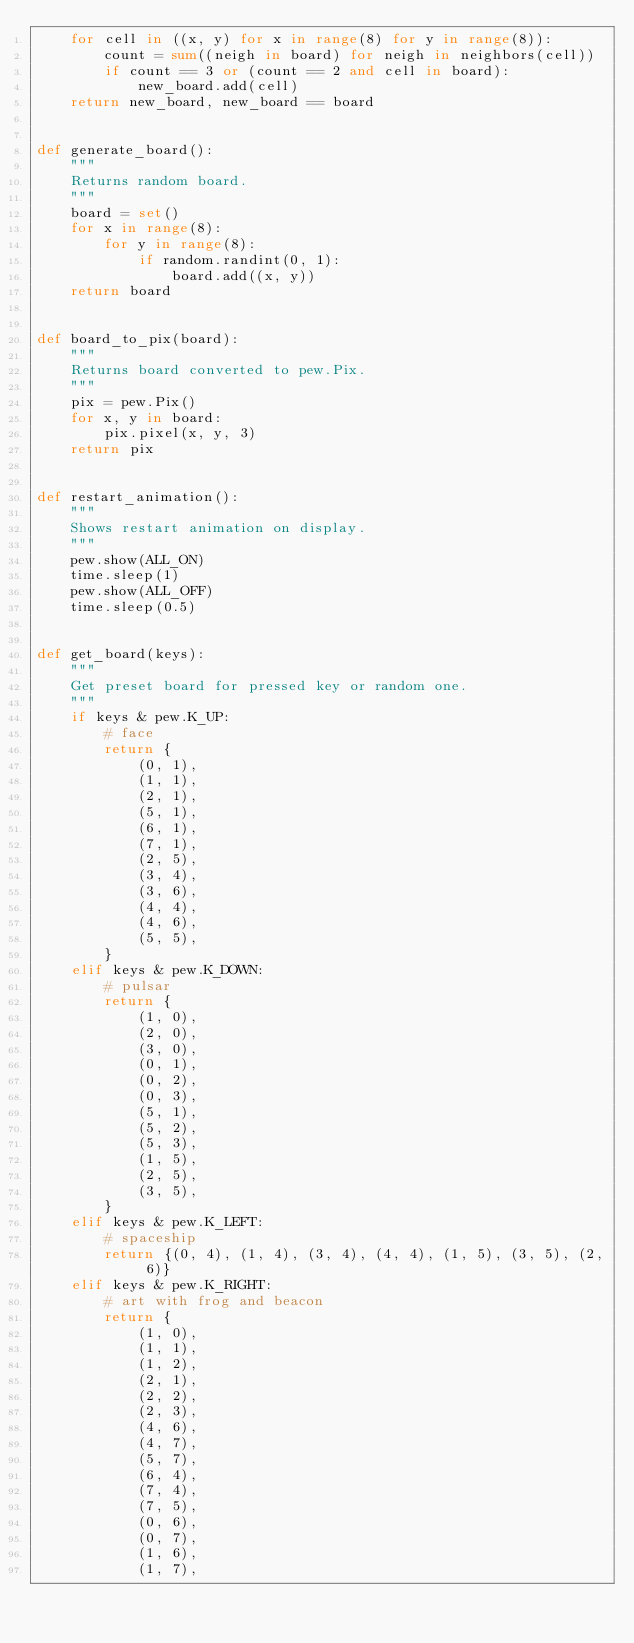<code> <loc_0><loc_0><loc_500><loc_500><_Python_>    for cell in ((x, y) for x in range(8) for y in range(8)):
        count = sum((neigh in board) for neigh in neighbors(cell))
        if count == 3 or (count == 2 and cell in board):
            new_board.add(cell)
    return new_board, new_board == board


def generate_board():
    """
    Returns random board.
    """
    board = set()
    for x in range(8):
        for y in range(8):
            if random.randint(0, 1):
                board.add((x, y))
    return board


def board_to_pix(board):
    """
    Returns board converted to pew.Pix.
    """
    pix = pew.Pix()
    for x, y in board:
        pix.pixel(x, y, 3)
    return pix


def restart_animation():
    """
    Shows restart animation on display.
    """
    pew.show(ALL_ON)
    time.sleep(1)
    pew.show(ALL_OFF)
    time.sleep(0.5)


def get_board(keys):
    """
    Get preset board for pressed key or random one.
    """
    if keys & pew.K_UP:
        # face
        return {
            (0, 1),
            (1, 1),
            (2, 1),
            (5, 1),
            (6, 1),
            (7, 1),
            (2, 5),
            (3, 4),
            (3, 6),
            (4, 4),
            (4, 6),
            (5, 5),
        }
    elif keys & pew.K_DOWN:
        # pulsar
        return {
            (1, 0),
            (2, 0),
            (3, 0),
            (0, 1),
            (0, 2),
            (0, 3),
            (5, 1),
            (5, 2),
            (5, 3),
            (1, 5),
            (2, 5),
            (3, 5),
        }
    elif keys & pew.K_LEFT:
        # spaceship
        return {(0, 4), (1, 4), (3, 4), (4, 4), (1, 5), (3, 5), (2, 6)}
    elif keys & pew.K_RIGHT:
        # art with frog and beacon
        return {
            (1, 0),
            (1, 1),
            (1, 2),
            (2, 1),
            (2, 2),
            (2, 3),
            (4, 6),
            (4, 7),
            (5, 7),
            (6, 4),
            (7, 4),
            (7, 5),
            (0, 6),
            (0, 7),
            (1, 6),
            (1, 7),</code> 